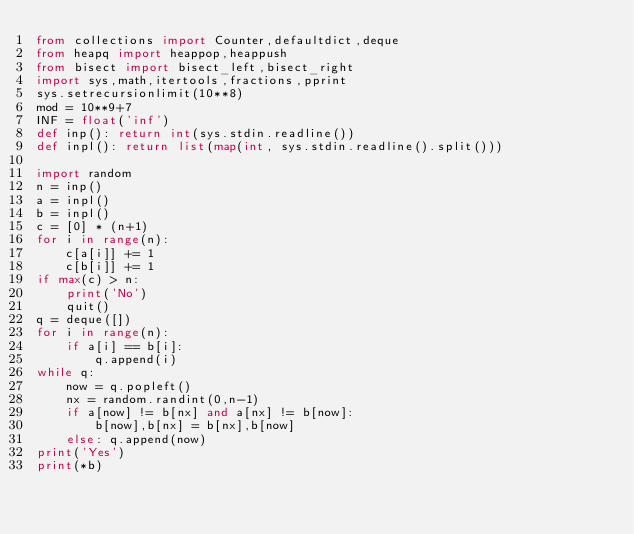Convert code to text. <code><loc_0><loc_0><loc_500><loc_500><_Python_>from collections import Counter,defaultdict,deque
from heapq import heappop,heappush
from bisect import bisect_left,bisect_right 
import sys,math,itertools,fractions,pprint
sys.setrecursionlimit(10**8)
mod = 10**9+7
INF = float('inf')
def inp(): return int(sys.stdin.readline())
def inpl(): return list(map(int, sys.stdin.readline().split()))

import random
n = inp()
a = inpl()
b = inpl()
c = [0] * (n+1)
for i in range(n):
    c[a[i]] += 1
    c[b[i]] += 1
if max(c) > n:
    print('No')
    quit()
q = deque([])
for i in range(n):
    if a[i] == b[i]:
        q.append(i)
while q:
    now = q.popleft()
    nx = random.randint(0,n-1)
    if a[now] != b[nx] and a[nx] != b[now]:
        b[now],b[nx] = b[nx],b[now]
    else: q.append(now)
print('Yes')
print(*b)</code> 